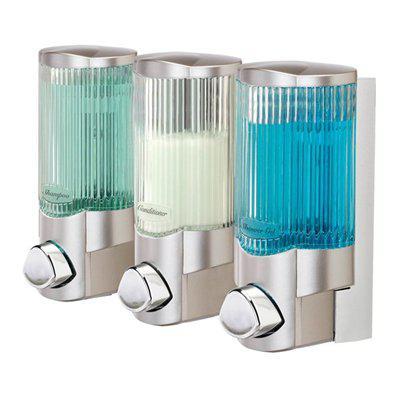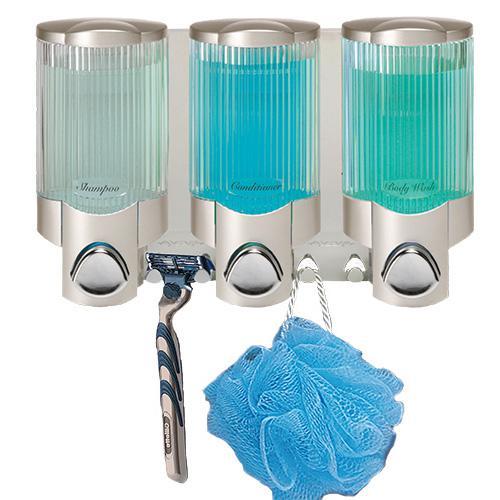The first image is the image on the left, the second image is the image on the right. Given the left and right images, does the statement "There is liquid filling at least five dispensers." hold true? Answer yes or no. Yes. The first image is the image on the left, the second image is the image on the right. Evaluate the accuracy of this statement regarding the images: "An image shows a trio of cylindrical dispensers that mount together, and one dispenses a white creamy-looking substance.". Is it true? Answer yes or no. Yes. 